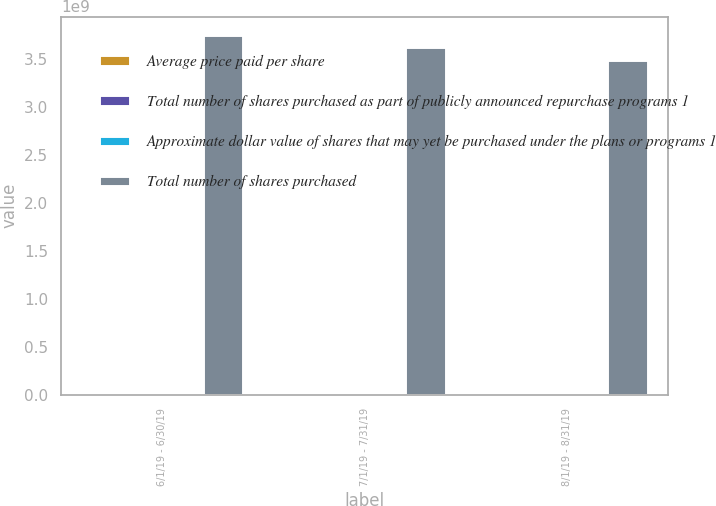Convert chart. <chart><loc_0><loc_0><loc_500><loc_500><stacked_bar_chart><ecel><fcel>6/1/19 - 6/30/19<fcel>7/1/19 - 7/31/19<fcel>8/1/19 - 8/31/19<nl><fcel>Average price paid per share<fcel>2.3846e+06<fcel>2.34849e+06<fcel>3.4984e+06<nl><fcel>Total number of shares purchased as part of publicly announced repurchase programs 1<fcel>51.94<fcel>55.02<fcel>51.97<nl><fcel>Approximate dollar value of shares that may yet be purchased under the plans or programs 1<fcel>2.3846e+06<fcel>2.34849e+06<fcel>2.5984e+06<nl><fcel>Total number of shares purchased<fcel>3.7534e+09<fcel>3.62417e+09<fcel>3.48971e+09<nl></chart> 